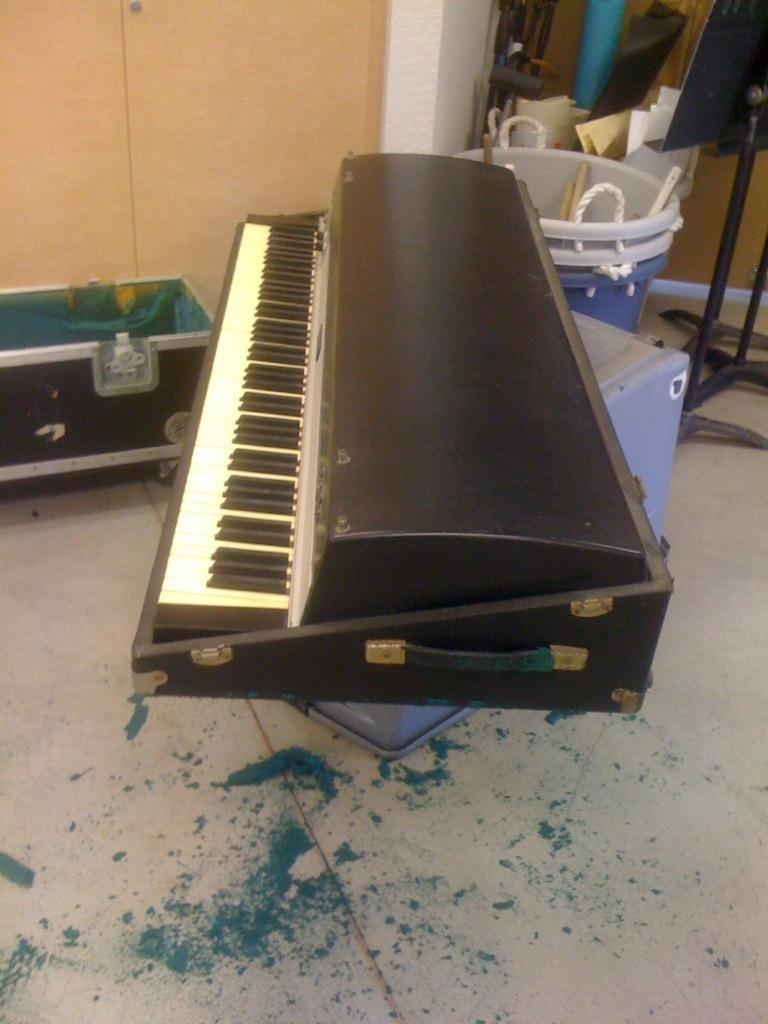What is the main object in the center of the image? There is a piano in the center of the image. What can be seen towards the left side of the image? There is a trunk towards the left side of the image. What objects are located towards the right side of the image? There are buckets, boards, and stands towards the right side of the image. How many books are stacked on the chairs in the image? There are no books or chairs present in the image. 